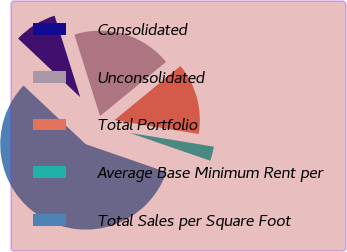<chart> <loc_0><loc_0><loc_500><loc_500><pie_chart><fcel>Consolidated<fcel>Unconsolidated<fcel>Total Portfolio<fcel>Average Base Minimum Rent per<fcel>Total Sales per Square Foot<nl><fcel>8.11%<fcel>18.92%<fcel>13.52%<fcel>2.71%<fcel>56.74%<nl></chart> 